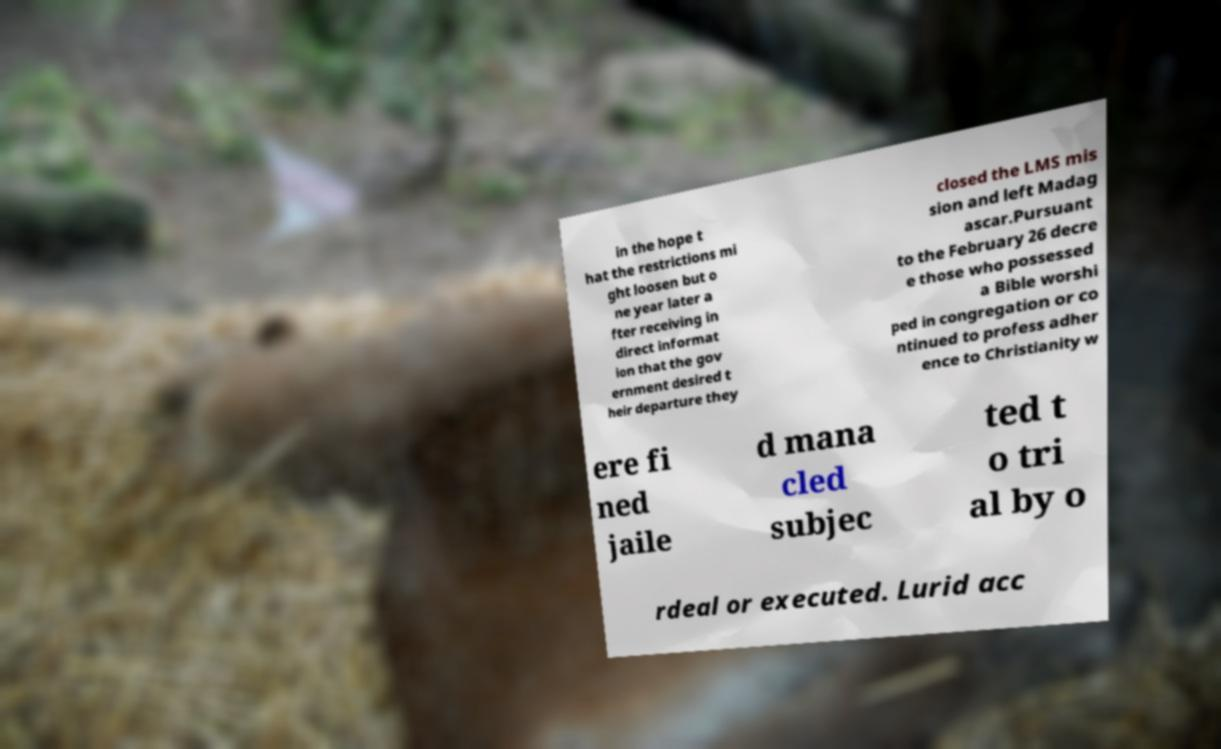For documentation purposes, I need the text within this image transcribed. Could you provide that? in the hope t hat the restrictions mi ght loosen but o ne year later a fter receiving in direct informat ion that the gov ernment desired t heir departure they closed the LMS mis sion and left Madag ascar.Pursuant to the February 26 decre e those who possessed a Bible worshi ped in congregation or co ntinued to profess adher ence to Christianity w ere fi ned jaile d mana cled subjec ted t o tri al by o rdeal or executed. Lurid acc 